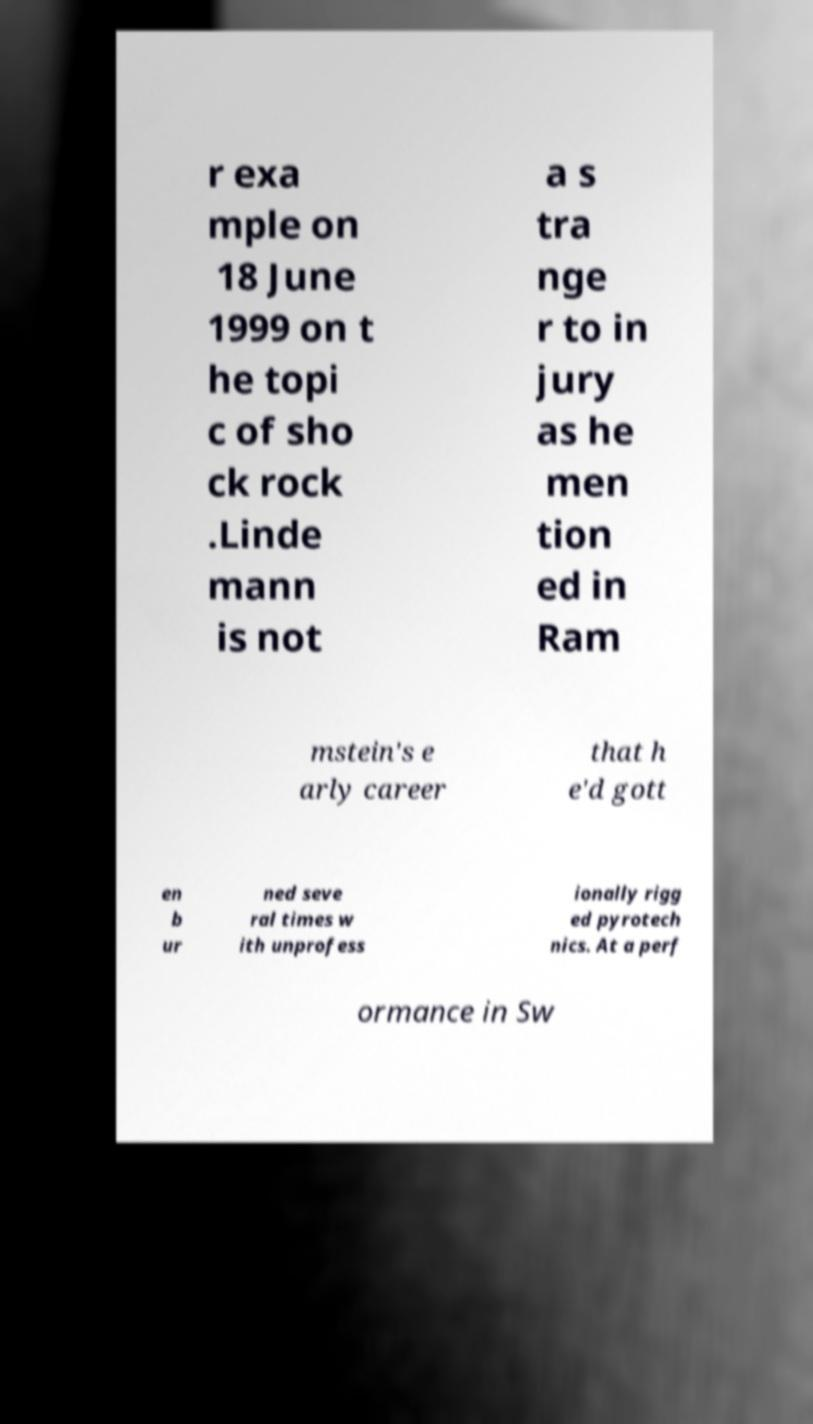Please identify and transcribe the text found in this image. r exa mple on 18 June 1999 on t he topi c of sho ck rock .Linde mann is not a s tra nge r to in jury as he men tion ed in Ram mstein's e arly career that h e'd gott en b ur ned seve ral times w ith unprofess ionally rigg ed pyrotech nics. At a perf ormance in Sw 